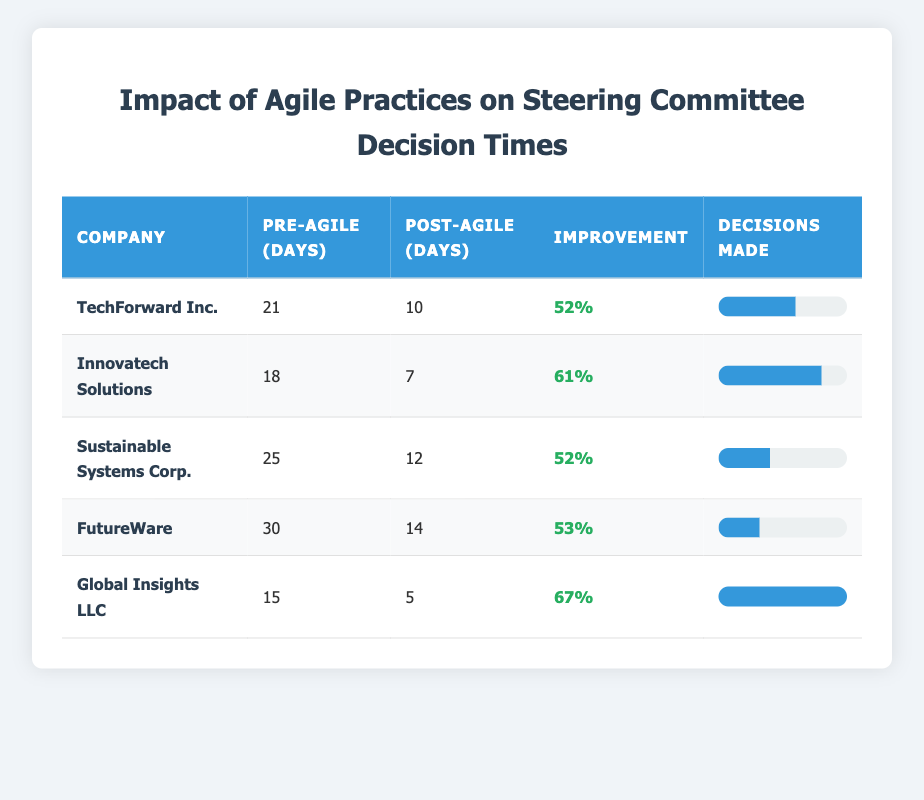What was the decision-making turnaround time for TechForward Inc. before adopting Agile practices? The table lists the pre-Agile turnaround time for TechForward Inc. as 21 days. This value is found directly in the table under the "Pre-Agile (days)" column for the corresponding company row.
Answer: 21 days How many decisions were made by Global Insights LLC after adopting Agile practices? The table indicates that Global Insights LLC made 25 decisions after adopting Agile practices, as found in the "Decisions Made" column for this company.
Answer: 25 What is the average pre-Agile turnaround time across all companies listed? To find the average, we sum the pre-Agile turnaround times: (21 + 18 + 25 + 30 + 15) = 109. There are 5 companies, so the average is 109 / 5 = 21.8.
Answer: 21.8 days Which company experienced the highest improvement in decision-making turnaround time after adopting Agile practices? Calculating the improvement percentages for each company reveals that Global Insights LLC had the highest improvement of 67%, as shown under the "Improvement" column.
Answer: Global Insights LLC Did any company have a post-Agile turnaround time greater than 15 days? Based on the table, only FutureWare has a post-Agile turnaround time of 14 days, which is not greater than 15. Since there are no entries above 15 days in the "Post-Agile (days)" column, the answer is no.
Answer: No What is the total number of decisions made post-Agile across all companies? Adding the number of decisions made after adopting Agile practices yields: (15 + 20 + 10 + 8 + 25) = 78 decisions made in total.
Answer: 78 decisions What was the percentage improvement for Sustainable Systems Corp.? The improvement is calculated as ((25 - 12) / 25) * 100, which equals 52%. This improvement is directly listed in the table under the "Improvement" column for this company.
Answer: 52% If we rank the companies by their pre-Agile turnaround time from highest to lowest, which company would rank second? The pre-Agile times sorted in descending order are: FutureWare (30), Sustainable Systems Corp. (25), TechForward Inc. (21), Innovatech Solutions (18), Global Insights LLC (15). The second in this ranking would be Sustainable Systems Corp.
Answer: Sustainable Systems Corp Is it true that TechForward Inc. had a post-Agile turnaround time that is exactly 50% less than its pre-Agile turnaround time? TechForward Inc.'s pre-Agile turnaround time was 21 days. Half of this is 10.5 days, while its post-Agile time is 10 days, which is less than 50%. Therefore, the statement is false.
Answer: No 